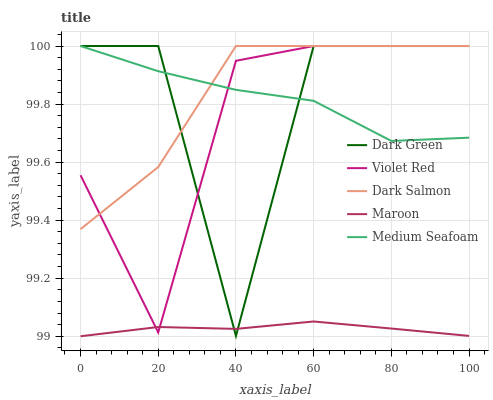Does Maroon have the minimum area under the curve?
Answer yes or no. Yes. Does Dark Salmon have the maximum area under the curve?
Answer yes or no. Yes. Does Medium Seafoam have the minimum area under the curve?
Answer yes or no. No. Does Medium Seafoam have the maximum area under the curve?
Answer yes or no. No. Is Maroon the smoothest?
Answer yes or no. Yes. Is Dark Green the roughest?
Answer yes or no. Yes. Is Medium Seafoam the smoothest?
Answer yes or no. No. Is Medium Seafoam the roughest?
Answer yes or no. No. Does Maroon have the lowest value?
Answer yes or no. Yes. Does Dark Salmon have the lowest value?
Answer yes or no. No. Does Dark Green have the highest value?
Answer yes or no. Yes. Does Maroon have the highest value?
Answer yes or no. No. Is Maroon less than Medium Seafoam?
Answer yes or no. Yes. Is Dark Salmon greater than Maroon?
Answer yes or no. Yes. Does Violet Red intersect Dark Green?
Answer yes or no. Yes. Is Violet Red less than Dark Green?
Answer yes or no. No. Is Violet Red greater than Dark Green?
Answer yes or no. No. Does Maroon intersect Medium Seafoam?
Answer yes or no. No. 